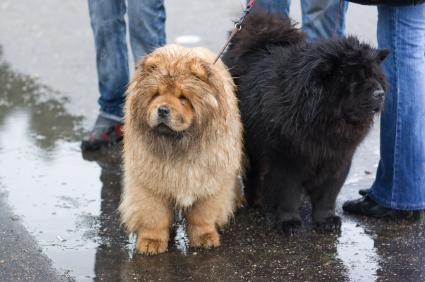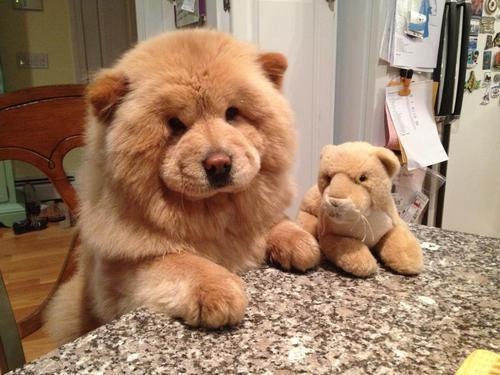The first image is the image on the left, the second image is the image on the right. Examine the images to the left and right. Is the description "One of the images contains at least three dogs." accurate? Answer yes or no. No. 